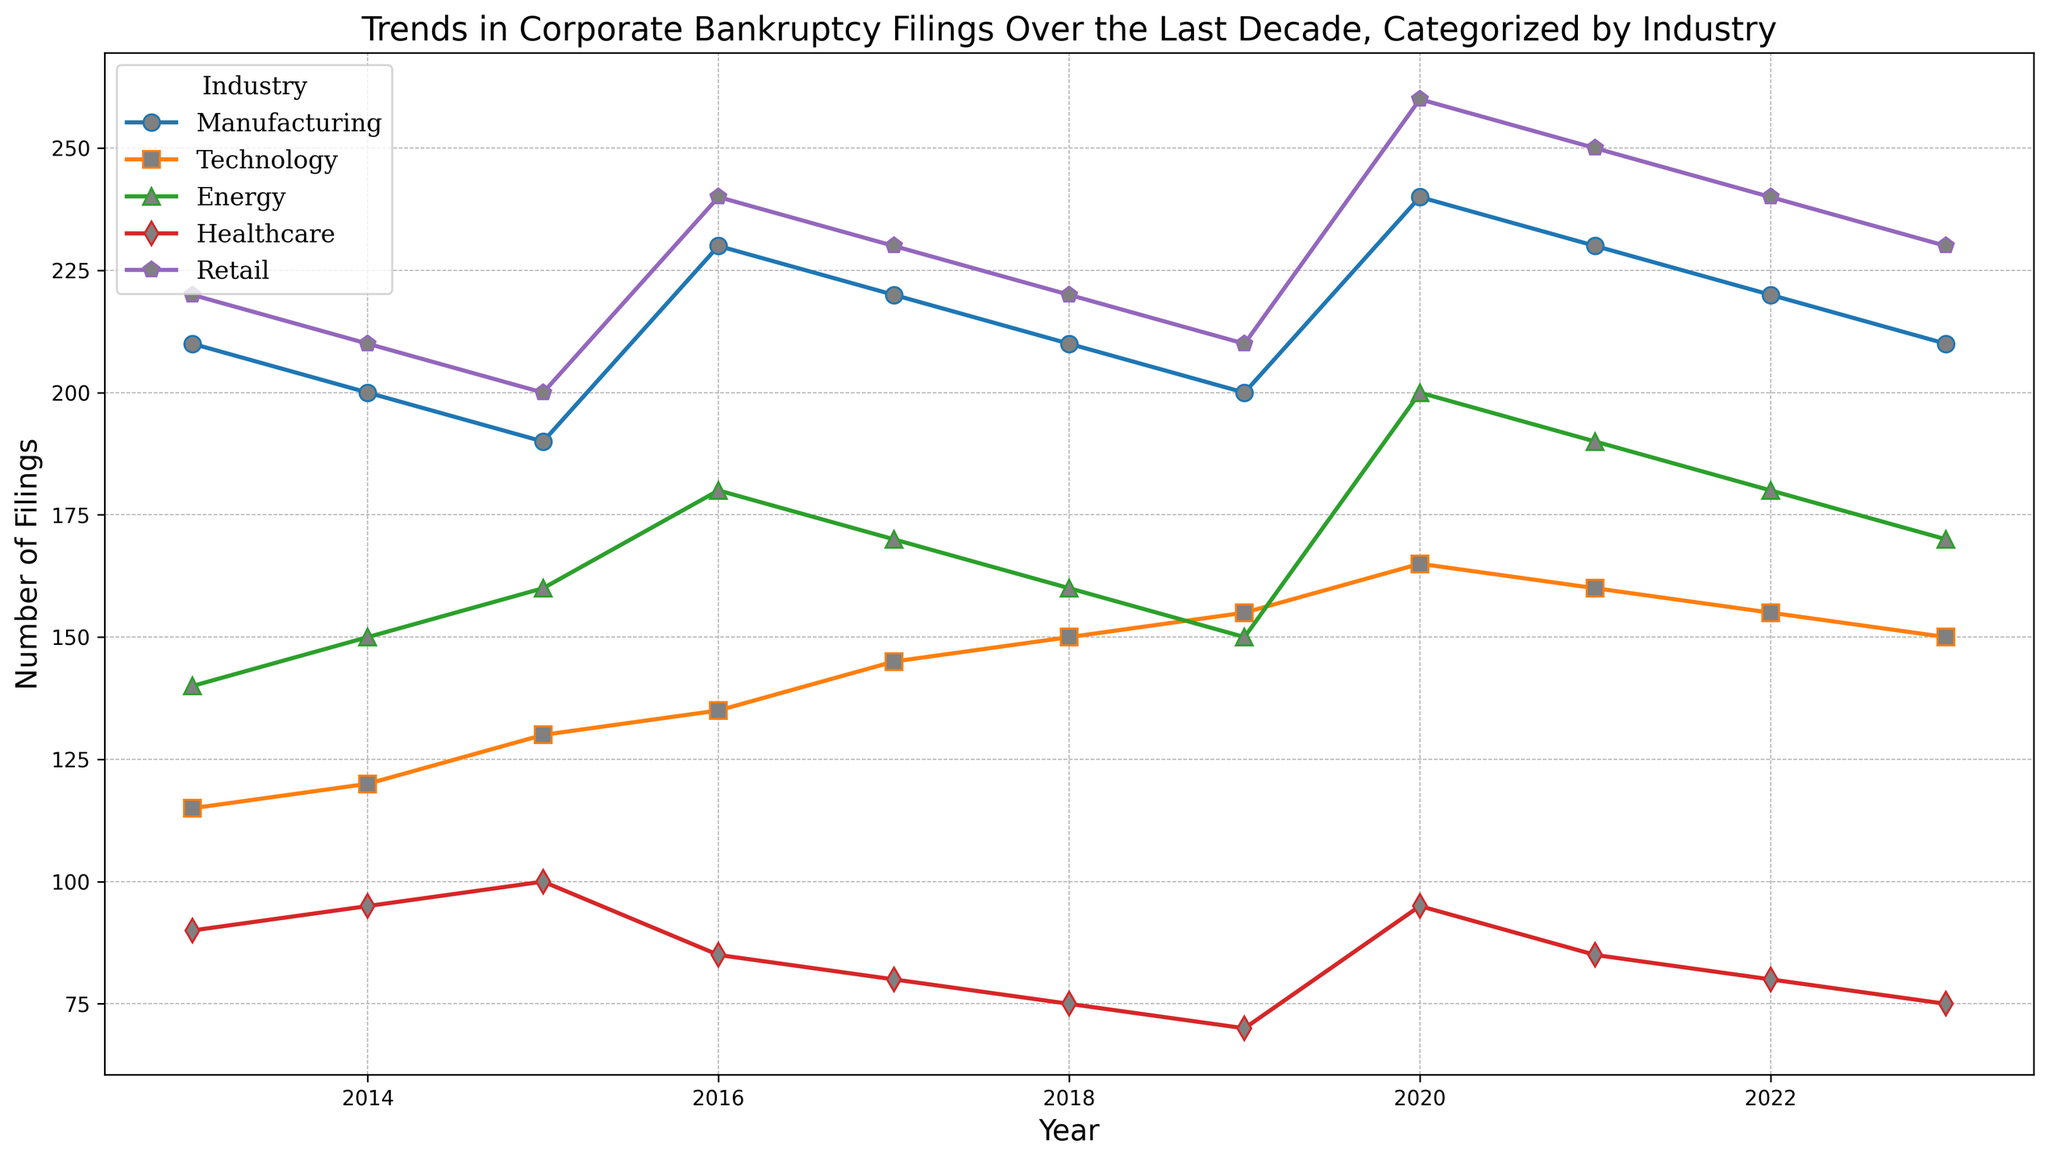What's the general trend in bankruptcy filings for the Retail industry over the last decade? The chart shows that the Retail industry follows a pattern where filings increase and decrease over the years. Starting high in 2013 with 220 filings, there is a slight drop until 2015 after which filings increase significantly, peaking at 260 in 2020, and then experiencing a small decline by 2023.
Answer: Increase and then slight decrease Which industry had the highest number of bankruptcy filings in 2020? By examining the year 2020 on the chart, the highest point among all industries can be observed in the Retail industry, which recorded 260 filings.
Answer: Retail Between 2013 and 2023, which industry shows the most consistent trend in bankruptcy filings? Observing the lines for each industry, the Technology industry shows a relatively consistent upward trend, with only minor variations in the number of filings each year.
Answer: Technology In what year did the Manufacturing industry experience its highest number of bankruptcy filings, and what was the number? The Manufacturing industry experienced its highest number of bankruptcy filings in the year 2020, with 240 filings as indicated by the peak on the chart for this industry.
Answer: 2020, 240 filings Compare the number of bankruptcy filings between Healthcare and Energy industries in 2016. Which industry had more filings and by how much? The chart shows that in 2016, the Energy industry had 180 filings, while the Healthcare industry had 85 filings. To find the difference, subtract 85 from 180.
Answer: Energy, by 95 filings Overall, which year saw the highest total number of bankruptcy filings across all industries? By summing the number of filings for all industries in each year, 2020 can be identified as having the highest total filings. Adding up the numbers: 240 (Manufacturing) + 165 (Technology) + 200 (Energy) + 95 (Healthcare) + 260 (Retail) equals 960.
Answer: 2020 In 2023, which industry observed the lowest number of filings and what is that number? The lowest line marker in 2023 belongs to the Healthcare industry, displaying 75 filings.
Answer: Healthcare, 75 How did bankruptcy filings in the Energy industry change from 2019 to 2020, and what is the percentage increase? The Energy industry had 150 filings in 2019 and 200 in 2020. The increase can be calculated as (200 - 150) = 50, and the percentage increase is (50/150) * 100%.
Answer: 50 filings, 33.33% Which two industries saw significant increases in filings from 2019 to 2020? Both Manufacturing and Energy industries show a clear rise in filings from 2019 to 2020. The Manufacturing industry went from 200 to 240, and the Energy industry from 150 to 200.
Answer: Manufacturing and Energy What is the average number of bankruptcy filings in the Technology industry over the decade? Adding up the number of filings each year for the Technology industry: 115 + 120 + 130 + 135 + 145 + 150 + 155 + 165 + 160 + 155 + 150 = 1580. The average is 1580/11.
Answer: 143.64 